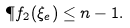<formula> <loc_0><loc_0><loc_500><loc_500>\P f _ { 2 } ( \xi _ { e } ) \leq n - 1 .</formula> 